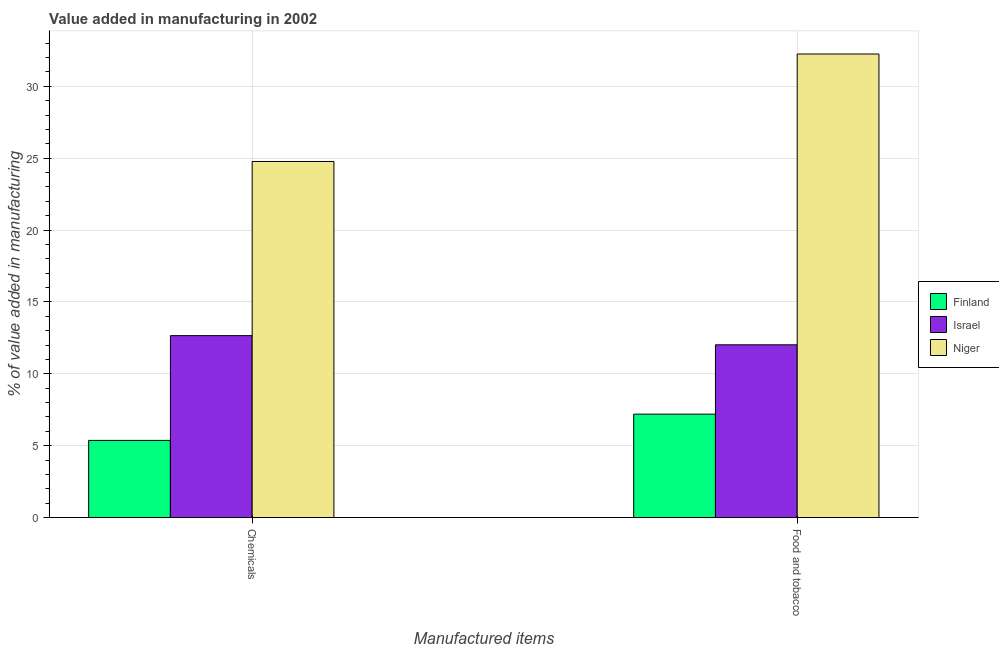How many groups of bars are there?
Provide a short and direct response. 2. How many bars are there on the 2nd tick from the left?
Give a very brief answer. 3. How many bars are there on the 2nd tick from the right?
Provide a short and direct response. 3. What is the label of the 1st group of bars from the left?
Provide a short and direct response. Chemicals. What is the value added by  manufacturing chemicals in Israel?
Your answer should be compact. 12.66. Across all countries, what is the maximum value added by  manufacturing chemicals?
Ensure brevity in your answer.  24.77. Across all countries, what is the minimum value added by  manufacturing chemicals?
Provide a short and direct response. 5.37. In which country was the value added by manufacturing food and tobacco maximum?
Give a very brief answer. Niger. In which country was the value added by  manufacturing chemicals minimum?
Ensure brevity in your answer.  Finland. What is the total value added by manufacturing food and tobacco in the graph?
Ensure brevity in your answer.  51.46. What is the difference between the value added by manufacturing food and tobacco in Niger and that in Finland?
Provide a short and direct response. 25.05. What is the difference between the value added by  manufacturing chemicals in Niger and the value added by manufacturing food and tobacco in Finland?
Your response must be concise. 17.58. What is the average value added by  manufacturing chemicals per country?
Make the answer very short. 14.27. What is the difference between the value added by  manufacturing chemicals and value added by manufacturing food and tobacco in Finland?
Offer a terse response. -1.83. What is the ratio of the value added by manufacturing food and tobacco in Israel to that in Niger?
Your answer should be compact. 0.37. What does the 1st bar from the left in Food and tobacco represents?
Provide a short and direct response. Finland. What does the 3rd bar from the right in Food and tobacco represents?
Give a very brief answer. Finland. How many countries are there in the graph?
Your response must be concise. 3. What is the difference between two consecutive major ticks on the Y-axis?
Provide a short and direct response. 5. Are the values on the major ticks of Y-axis written in scientific E-notation?
Ensure brevity in your answer.  No. Does the graph contain any zero values?
Ensure brevity in your answer.  No. Does the graph contain grids?
Your answer should be compact. Yes. Where does the legend appear in the graph?
Your answer should be compact. Center right. How many legend labels are there?
Your answer should be compact. 3. What is the title of the graph?
Your answer should be very brief. Value added in manufacturing in 2002. What is the label or title of the X-axis?
Provide a succinct answer. Manufactured items. What is the label or title of the Y-axis?
Ensure brevity in your answer.  % of value added in manufacturing. What is the % of value added in manufacturing in Finland in Chemicals?
Make the answer very short. 5.37. What is the % of value added in manufacturing of Israel in Chemicals?
Provide a short and direct response. 12.66. What is the % of value added in manufacturing in Niger in Chemicals?
Offer a terse response. 24.77. What is the % of value added in manufacturing of Finland in Food and tobacco?
Give a very brief answer. 7.19. What is the % of value added in manufacturing in Israel in Food and tobacco?
Ensure brevity in your answer.  12.02. What is the % of value added in manufacturing in Niger in Food and tobacco?
Make the answer very short. 32.25. Across all Manufactured items, what is the maximum % of value added in manufacturing in Finland?
Ensure brevity in your answer.  7.19. Across all Manufactured items, what is the maximum % of value added in manufacturing in Israel?
Give a very brief answer. 12.66. Across all Manufactured items, what is the maximum % of value added in manufacturing of Niger?
Give a very brief answer. 32.25. Across all Manufactured items, what is the minimum % of value added in manufacturing in Finland?
Offer a very short reply. 5.37. Across all Manufactured items, what is the minimum % of value added in manufacturing in Israel?
Offer a very short reply. 12.02. Across all Manufactured items, what is the minimum % of value added in manufacturing in Niger?
Offer a terse response. 24.77. What is the total % of value added in manufacturing in Finland in the graph?
Your answer should be very brief. 12.56. What is the total % of value added in manufacturing of Israel in the graph?
Offer a terse response. 24.67. What is the total % of value added in manufacturing in Niger in the graph?
Your answer should be very brief. 57.02. What is the difference between the % of value added in manufacturing in Finland in Chemicals and that in Food and tobacco?
Give a very brief answer. -1.83. What is the difference between the % of value added in manufacturing of Israel in Chemicals and that in Food and tobacco?
Keep it short and to the point. 0.64. What is the difference between the % of value added in manufacturing of Niger in Chemicals and that in Food and tobacco?
Keep it short and to the point. -7.48. What is the difference between the % of value added in manufacturing of Finland in Chemicals and the % of value added in manufacturing of Israel in Food and tobacco?
Offer a terse response. -6.65. What is the difference between the % of value added in manufacturing in Finland in Chemicals and the % of value added in manufacturing in Niger in Food and tobacco?
Your answer should be very brief. -26.88. What is the difference between the % of value added in manufacturing in Israel in Chemicals and the % of value added in manufacturing in Niger in Food and tobacco?
Make the answer very short. -19.59. What is the average % of value added in manufacturing of Finland per Manufactured items?
Keep it short and to the point. 6.28. What is the average % of value added in manufacturing of Israel per Manufactured items?
Your response must be concise. 12.34. What is the average % of value added in manufacturing of Niger per Manufactured items?
Give a very brief answer. 28.51. What is the difference between the % of value added in manufacturing in Finland and % of value added in manufacturing in Israel in Chemicals?
Your response must be concise. -7.29. What is the difference between the % of value added in manufacturing in Finland and % of value added in manufacturing in Niger in Chemicals?
Make the answer very short. -19.4. What is the difference between the % of value added in manufacturing in Israel and % of value added in manufacturing in Niger in Chemicals?
Your answer should be compact. -12.12. What is the difference between the % of value added in manufacturing of Finland and % of value added in manufacturing of Israel in Food and tobacco?
Provide a succinct answer. -4.82. What is the difference between the % of value added in manufacturing of Finland and % of value added in manufacturing of Niger in Food and tobacco?
Offer a terse response. -25.05. What is the difference between the % of value added in manufacturing of Israel and % of value added in manufacturing of Niger in Food and tobacco?
Ensure brevity in your answer.  -20.23. What is the ratio of the % of value added in manufacturing of Finland in Chemicals to that in Food and tobacco?
Keep it short and to the point. 0.75. What is the ratio of the % of value added in manufacturing in Israel in Chemicals to that in Food and tobacco?
Provide a short and direct response. 1.05. What is the ratio of the % of value added in manufacturing in Niger in Chemicals to that in Food and tobacco?
Provide a short and direct response. 0.77. What is the difference between the highest and the second highest % of value added in manufacturing of Finland?
Offer a terse response. 1.83. What is the difference between the highest and the second highest % of value added in manufacturing of Israel?
Offer a terse response. 0.64. What is the difference between the highest and the second highest % of value added in manufacturing of Niger?
Offer a very short reply. 7.48. What is the difference between the highest and the lowest % of value added in manufacturing of Finland?
Your response must be concise. 1.83. What is the difference between the highest and the lowest % of value added in manufacturing of Israel?
Your answer should be compact. 0.64. What is the difference between the highest and the lowest % of value added in manufacturing in Niger?
Offer a very short reply. 7.48. 